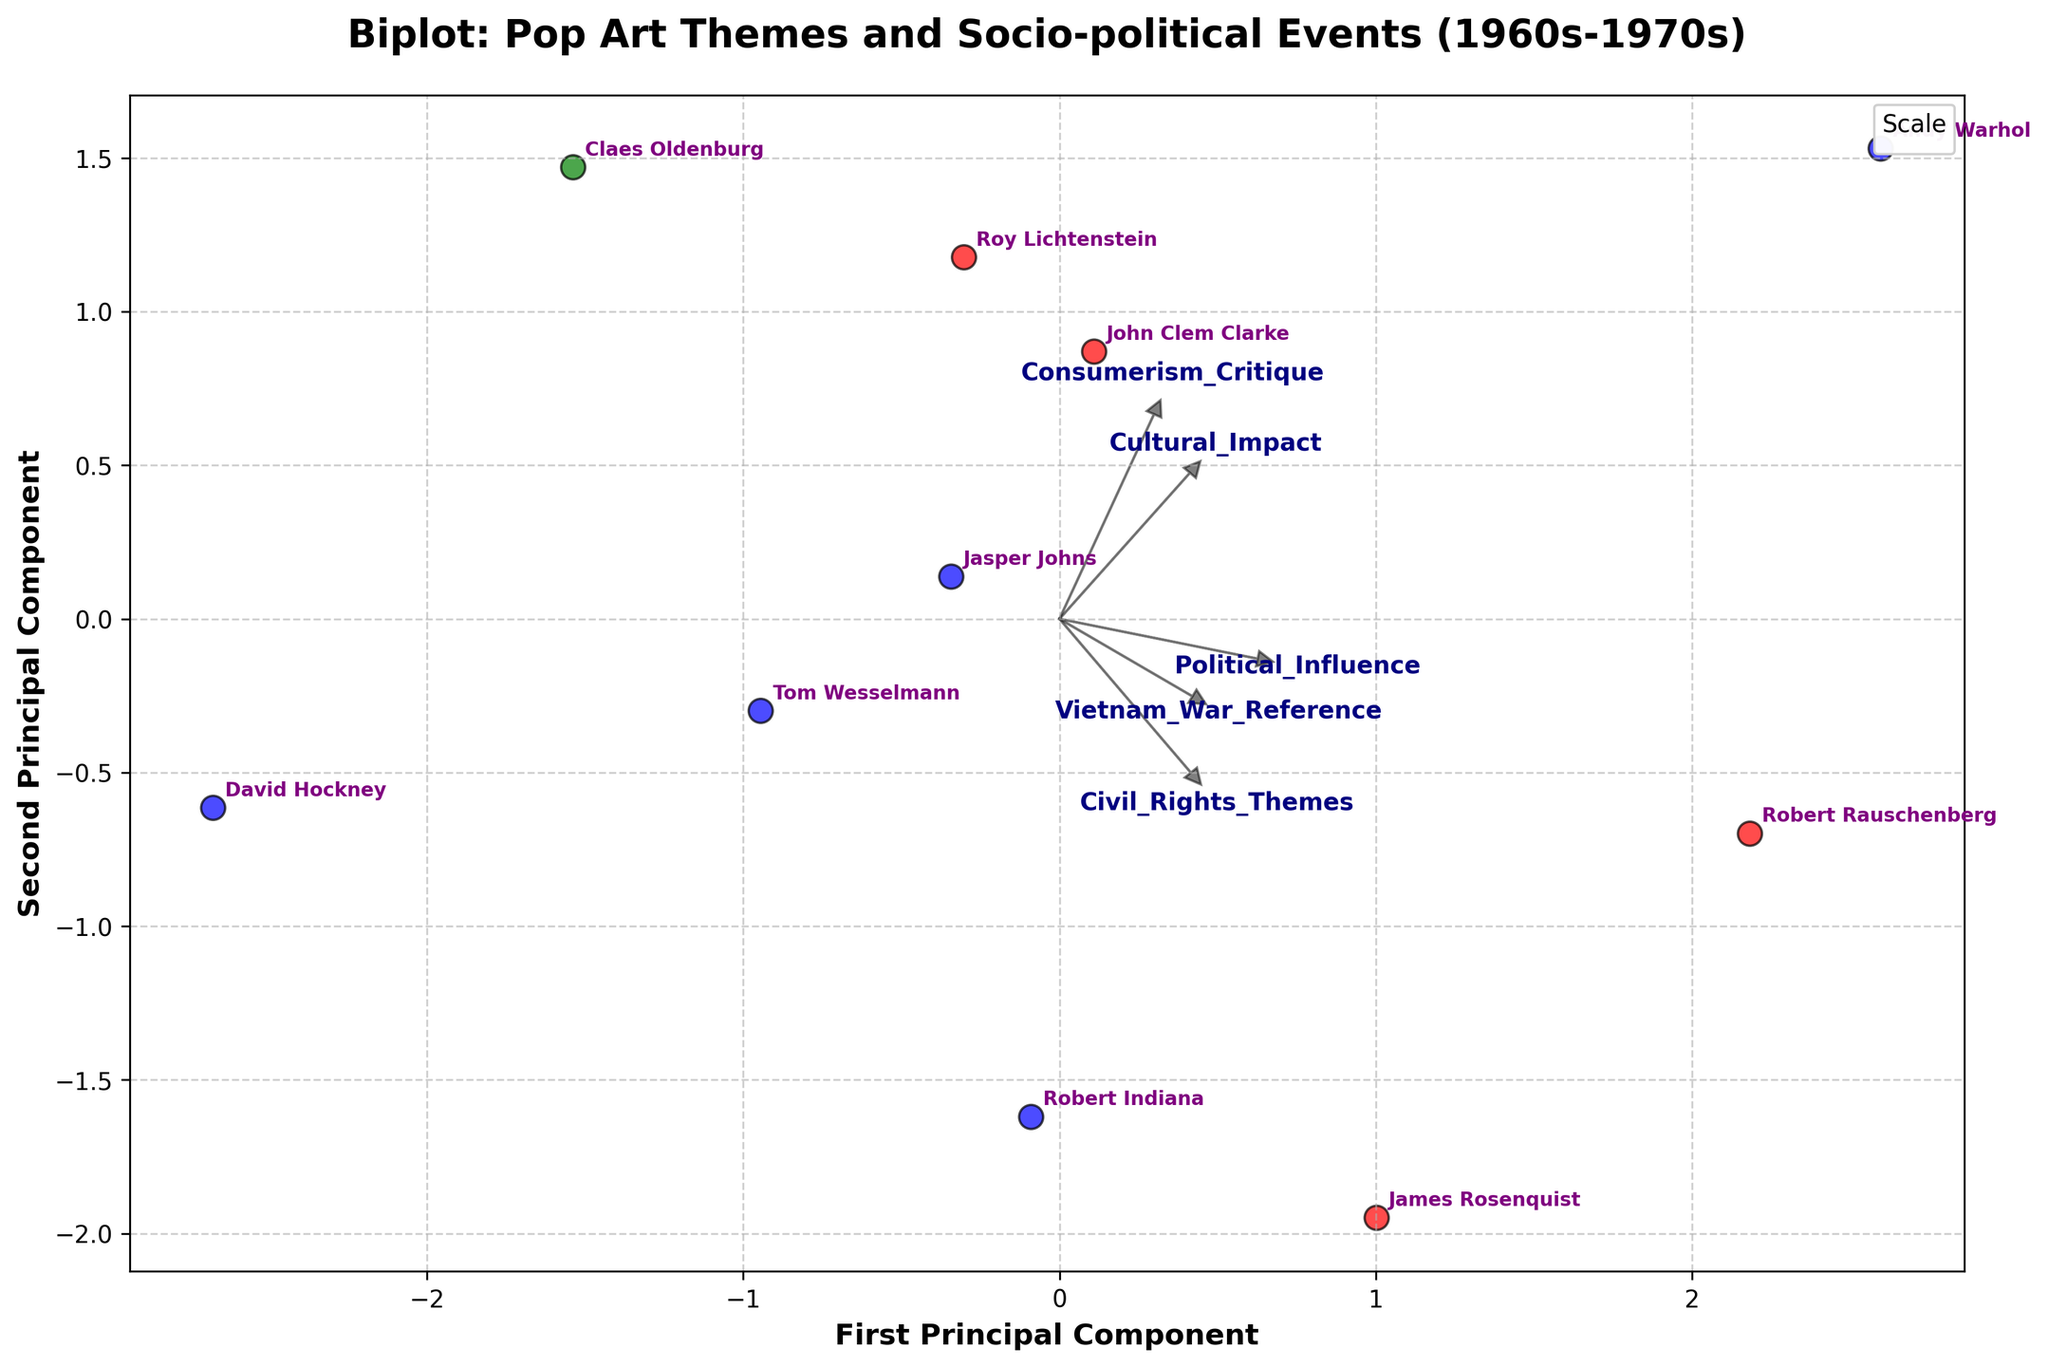What is the title of the biplot? The title of the plot is usually displayed at the top of the figure and indicates the main topic or focus of the plot. In this case, the title is "Biplot: Pop Art Themes and Socio-political Events (1960s-1970s)".
Answer: Biplot: Pop Art Themes and Socio-political Events (1960s-1970s) How many different scales are represented in the biplot, and what are they? By observing the legend in the figure, we can see distinct colored markers corresponding to different scales. The scales are "Large," "Medium," and "Monumental".
Answer: Three: Large, Medium, Monumental Which artist is closest to the origin of the biplot? The artist closest to the origin (0,0) on the biplot can be identified by looking at the proximity of the data points to the center.
Answer: David Hockney Which artist has the largest score on the first principal component (horizontal axis)? To find this, we need to look at the data point that is furthest to the right on the horizontal axis.
Answer: Andy Warhol Which feature vector points most in the direction of Political_Influence? Feature vectors are represented by arrows in a biplot. The arrow pointing most in the direction of Political_Influence should be the one that forms the largest angle with the axis in the direction correlated with that component.
Answer: Cultural_Impact Is the Vietnam_War_Reference vector more aligned with the first principal component or the second principal component? By observing the direction of the arrow corresponding to Vietnam_War_Reference, we can see whether it points more horizontally (first principal component) or vertically (second principal component).
Answer: First principal component Which artist has representations with strong Consumerism_Critique but lesser Civil_Rights_Themes? This question requires looking at the placement of artists' data points in relation to the feature vectors Consumerism_Critique and Civil_Rights_Themes. The artist sharing characteristics close to Consumerism_Critique but away from Civil_Rights_Themes needs to be identified.
Answer: John Clem Clarke Are the political themes (such as Vietnam_War_Reference and Civil_Rights_Themes) more correlated with each other or with consumerism-related themes (such as Consumerism_Critique)? This question requires carefully observing the directions of the arrows: the angles between the vectors for Vietnam_War_Reference and Civil_Rights_Themes versus the vector for Consumerism_Critique. Smaller angles indicate a higher degree of correlation.
Answer: Vietnam_War_Reference and Civil_Rights_Themes are more correlated with each other Which artist among those using sculpture has a more significant political theme influence? By identifying artists using sculpture and comparing their proximity to the Political_Influence vector, we can determine who has a strong political theme influence. Relevant artists are Claes Oldenburg and Robert Indiana. Claes Oldenburg is more prominently aligned with political vectors.
Answer: Claes Oldenburg How do works using medium scale (Medium) compare with those using large scale (Large) in terms of Cultural_Impact? The medium scale group (blue markers) and large scale group (red markers) can be compared in terms of their alignment and spread along the Cultural_Impact vector. Observing their effect will give a reasonable comparison.
Answer: Large scale seems more diverse in Cultural_Impact while medium scale is relatively moderate and consistent 